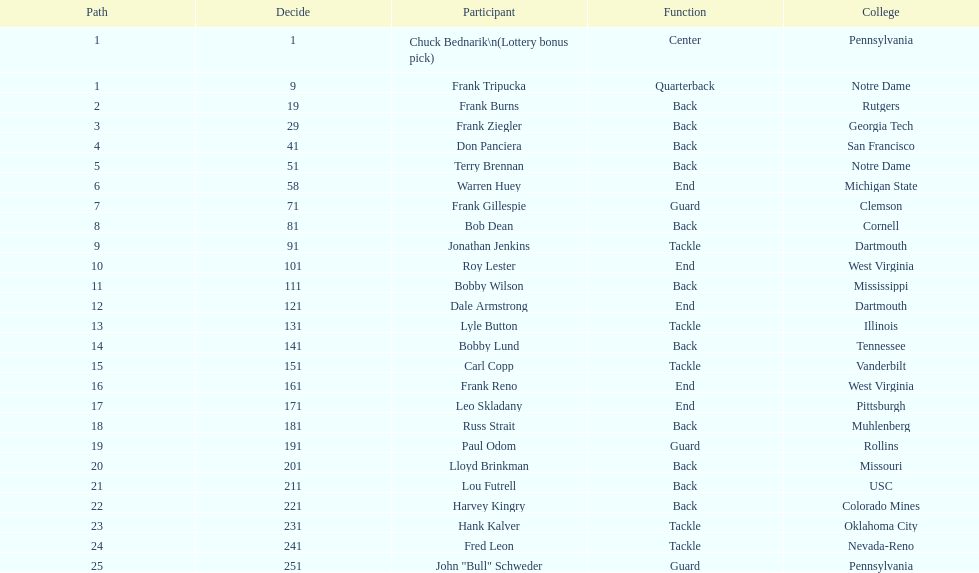How many players were from notre dame? 2. 